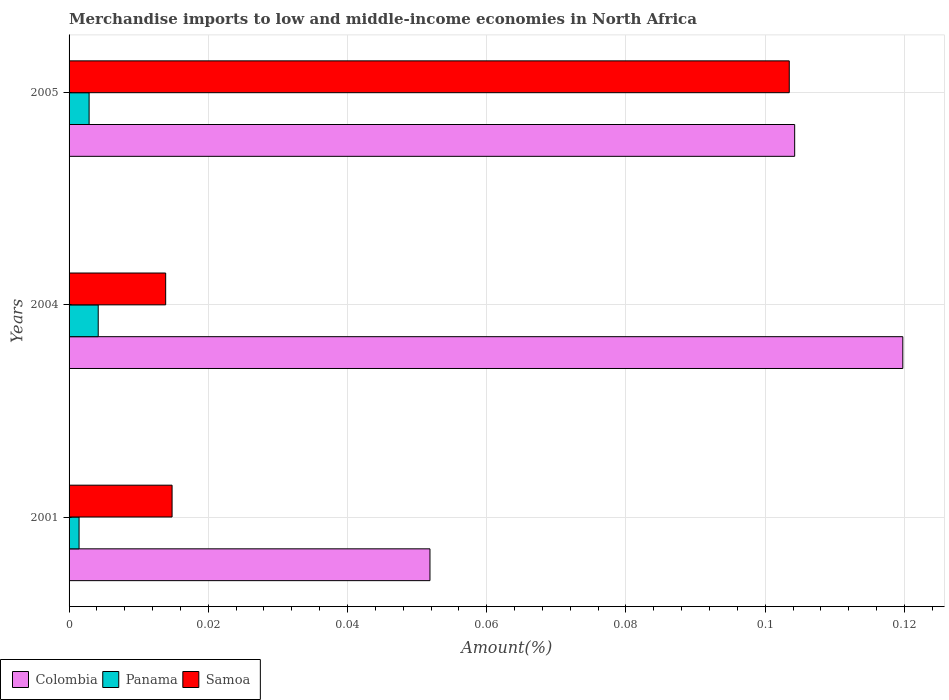How many different coloured bars are there?
Give a very brief answer. 3. How many groups of bars are there?
Keep it short and to the point. 3. Are the number of bars on each tick of the Y-axis equal?
Give a very brief answer. Yes. How many bars are there on the 3rd tick from the top?
Make the answer very short. 3. How many bars are there on the 3rd tick from the bottom?
Make the answer very short. 3. What is the percentage of amount earned from merchandise imports in Samoa in 2001?
Provide a succinct answer. 0.01. Across all years, what is the maximum percentage of amount earned from merchandise imports in Panama?
Provide a succinct answer. 0. Across all years, what is the minimum percentage of amount earned from merchandise imports in Panama?
Provide a short and direct response. 0. In which year was the percentage of amount earned from merchandise imports in Samoa maximum?
Offer a very short reply. 2005. What is the total percentage of amount earned from merchandise imports in Colombia in the graph?
Offer a terse response. 0.28. What is the difference between the percentage of amount earned from merchandise imports in Samoa in 2001 and that in 2005?
Ensure brevity in your answer.  -0.09. What is the difference between the percentage of amount earned from merchandise imports in Samoa in 2004 and the percentage of amount earned from merchandise imports in Colombia in 2001?
Offer a very short reply. -0.04. What is the average percentage of amount earned from merchandise imports in Panama per year?
Your answer should be very brief. 0. In the year 2001, what is the difference between the percentage of amount earned from merchandise imports in Samoa and percentage of amount earned from merchandise imports in Colombia?
Provide a succinct answer. -0.04. In how many years, is the percentage of amount earned from merchandise imports in Panama greater than 0.036000000000000004 %?
Offer a very short reply. 0. What is the ratio of the percentage of amount earned from merchandise imports in Colombia in 2001 to that in 2005?
Your answer should be compact. 0.5. Is the difference between the percentage of amount earned from merchandise imports in Samoa in 2001 and 2004 greater than the difference between the percentage of amount earned from merchandise imports in Colombia in 2001 and 2004?
Keep it short and to the point. Yes. What is the difference between the highest and the second highest percentage of amount earned from merchandise imports in Samoa?
Keep it short and to the point. 0.09. What is the difference between the highest and the lowest percentage of amount earned from merchandise imports in Samoa?
Your answer should be very brief. 0.09. In how many years, is the percentage of amount earned from merchandise imports in Colombia greater than the average percentage of amount earned from merchandise imports in Colombia taken over all years?
Offer a terse response. 2. Is the sum of the percentage of amount earned from merchandise imports in Colombia in 2001 and 2005 greater than the maximum percentage of amount earned from merchandise imports in Panama across all years?
Provide a short and direct response. Yes. What does the 1st bar from the bottom in 2004 represents?
Offer a terse response. Colombia. Is it the case that in every year, the sum of the percentage of amount earned from merchandise imports in Colombia and percentage of amount earned from merchandise imports in Panama is greater than the percentage of amount earned from merchandise imports in Samoa?
Give a very brief answer. Yes. How many bars are there?
Your answer should be very brief. 9. What is the difference between two consecutive major ticks on the X-axis?
Your response must be concise. 0.02. How many legend labels are there?
Your answer should be very brief. 3. What is the title of the graph?
Give a very brief answer. Merchandise imports to low and middle-income economies in North Africa. What is the label or title of the X-axis?
Your answer should be compact. Amount(%). What is the Amount(%) of Colombia in 2001?
Keep it short and to the point. 0.05. What is the Amount(%) in Panama in 2001?
Provide a short and direct response. 0. What is the Amount(%) of Samoa in 2001?
Make the answer very short. 0.01. What is the Amount(%) of Colombia in 2004?
Make the answer very short. 0.12. What is the Amount(%) in Panama in 2004?
Provide a succinct answer. 0. What is the Amount(%) of Samoa in 2004?
Keep it short and to the point. 0.01. What is the Amount(%) in Colombia in 2005?
Offer a very short reply. 0.1. What is the Amount(%) of Panama in 2005?
Your answer should be compact. 0. What is the Amount(%) in Samoa in 2005?
Keep it short and to the point. 0.1. Across all years, what is the maximum Amount(%) of Colombia?
Your response must be concise. 0.12. Across all years, what is the maximum Amount(%) in Panama?
Provide a succinct answer. 0. Across all years, what is the maximum Amount(%) in Samoa?
Your response must be concise. 0.1. Across all years, what is the minimum Amount(%) in Colombia?
Provide a succinct answer. 0.05. Across all years, what is the minimum Amount(%) of Panama?
Provide a short and direct response. 0. Across all years, what is the minimum Amount(%) in Samoa?
Keep it short and to the point. 0.01. What is the total Amount(%) in Colombia in the graph?
Ensure brevity in your answer.  0.28. What is the total Amount(%) of Panama in the graph?
Provide a short and direct response. 0.01. What is the total Amount(%) in Samoa in the graph?
Keep it short and to the point. 0.13. What is the difference between the Amount(%) of Colombia in 2001 and that in 2004?
Offer a terse response. -0.07. What is the difference between the Amount(%) in Panama in 2001 and that in 2004?
Keep it short and to the point. -0. What is the difference between the Amount(%) in Samoa in 2001 and that in 2004?
Your response must be concise. 0. What is the difference between the Amount(%) in Colombia in 2001 and that in 2005?
Provide a short and direct response. -0.05. What is the difference between the Amount(%) of Panama in 2001 and that in 2005?
Make the answer very short. -0. What is the difference between the Amount(%) in Samoa in 2001 and that in 2005?
Provide a succinct answer. -0.09. What is the difference between the Amount(%) of Colombia in 2004 and that in 2005?
Your answer should be compact. 0.02. What is the difference between the Amount(%) of Panama in 2004 and that in 2005?
Provide a succinct answer. 0. What is the difference between the Amount(%) in Samoa in 2004 and that in 2005?
Offer a very short reply. -0.09. What is the difference between the Amount(%) in Colombia in 2001 and the Amount(%) in Panama in 2004?
Provide a succinct answer. 0.05. What is the difference between the Amount(%) of Colombia in 2001 and the Amount(%) of Samoa in 2004?
Your answer should be compact. 0.04. What is the difference between the Amount(%) in Panama in 2001 and the Amount(%) in Samoa in 2004?
Make the answer very short. -0.01. What is the difference between the Amount(%) in Colombia in 2001 and the Amount(%) in Panama in 2005?
Provide a short and direct response. 0.05. What is the difference between the Amount(%) of Colombia in 2001 and the Amount(%) of Samoa in 2005?
Offer a very short reply. -0.05. What is the difference between the Amount(%) in Panama in 2001 and the Amount(%) in Samoa in 2005?
Provide a succinct answer. -0.1. What is the difference between the Amount(%) in Colombia in 2004 and the Amount(%) in Panama in 2005?
Provide a succinct answer. 0.12. What is the difference between the Amount(%) in Colombia in 2004 and the Amount(%) in Samoa in 2005?
Your answer should be compact. 0.02. What is the difference between the Amount(%) in Panama in 2004 and the Amount(%) in Samoa in 2005?
Ensure brevity in your answer.  -0.1. What is the average Amount(%) of Colombia per year?
Provide a succinct answer. 0.09. What is the average Amount(%) in Panama per year?
Offer a terse response. 0. What is the average Amount(%) of Samoa per year?
Your response must be concise. 0.04. In the year 2001, what is the difference between the Amount(%) in Colombia and Amount(%) in Panama?
Provide a succinct answer. 0.05. In the year 2001, what is the difference between the Amount(%) of Colombia and Amount(%) of Samoa?
Ensure brevity in your answer.  0.04. In the year 2001, what is the difference between the Amount(%) of Panama and Amount(%) of Samoa?
Make the answer very short. -0.01. In the year 2004, what is the difference between the Amount(%) of Colombia and Amount(%) of Panama?
Make the answer very short. 0.12. In the year 2004, what is the difference between the Amount(%) in Colombia and Amount(%) in Samoa?
Provide a succinct answer. 0.11. In the year 2004, what is the difference between the Amount(%) in Panama and Amount(%) in Samoa?
Make the answer very short. -0.01. In the year 2005, what is the difference between the Amount(%) in Colombia and Amount(%) in Panama?
Your response must be concise. 0.1. In the year 2005, what is the difference between the Amount(%) of Colombia and Amount(%) of Samoa?
Ensure brevity in your answer.  0. In the year 2005, what is the difference between the Amount(%) of Panama and Amount(%) of Samoa?
Offer a very short reply. -0.1. What is the ratio of the Amount(%) in Colombia in 2001 to that in 2004?
Make the answer very short. 0.43. What is the ratio of the Amount(%) in Panama in 2001 to that in 2004?
Ensure brevity in your answer.  0.34. What is the ratio of the Amount(%) in Samoa in 2001 to that in 2004?
Provide a short and direct response. 1.07. What is the ratio of the Amount(%) of Colombia in 2001 to that in 2005?
Your response must be concise. 0.5. What is the ratio of the Amount(%) of Panama in 2001 to that in 2005?
Provide a succinct answer. 0.5. What is the ratio of the Amount(%) of Samoa in 2001 to that in 2005?
Your answer should be very brief. 0.14. What is the ratio of the Amount(%) of Colombia in 2004 to that in 2005?
Give a very brief answer. 1.15. What is the ratio of the Amount(%) in Panama in 2004 to that in 2005?
Your answer should be compact. 1.46. What is the ratio of the Amount(%) in Samoa in 2004 to that in 2005?
Make the answer very short. 0.13. What is the difference between the highest and the second highest Amount(%) in Colombia?
Provide a short and direct response. 0.02. What is the difference between the highest and the second highest Amount(%) of Panama?
Give a very brief answer. 0. What is the difference between the highest and the second highest Amount(%) in Samoa?
Ensure brevity in your answer.  0.09. What is the difference between the highest and the lowest Amount(%) of Colombia?
Your answer should be very brief. 0.07. What is the difference between the highest and the lowest Amount(%) of Panama?
Ensure brevity in your answer.  0. What is the difference between the highest and the lowest Amount(%) in Samoa?
Your answer should be compact. 0.09. 